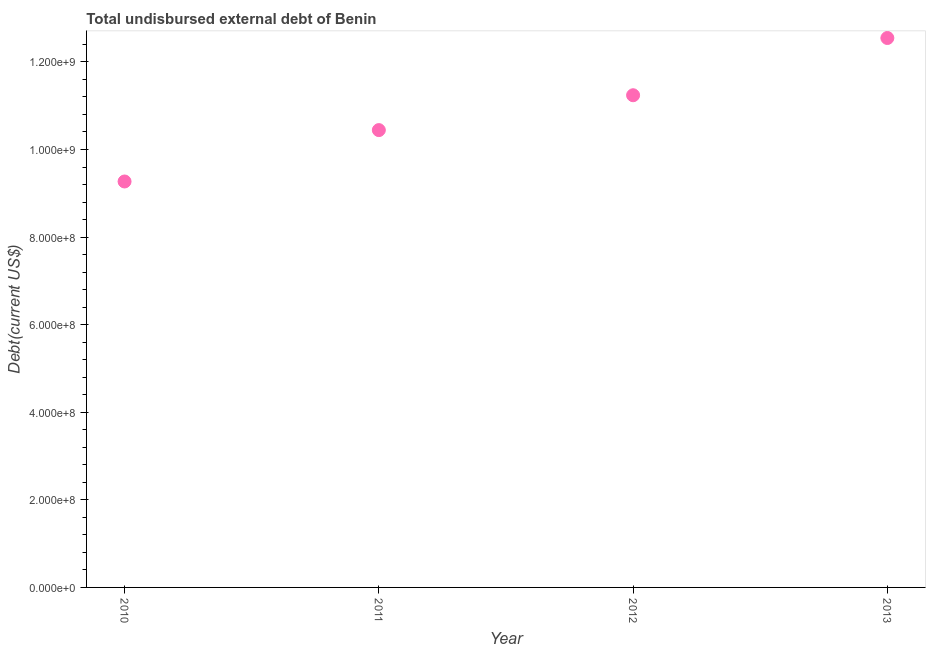What is the total debt in 2013?
Your response must be concise. 1.25e+09. Across all years, what is the maximum total debt?
Ensure brevity in your answer.  1.25e+09. Across all years, what is the minimum total debt?
Your answer should be very brief. 9.27e+08. In which year was the total debt maximum?
Your answer should be very brief. 2013. In which year was the total debt minimum?
Your response must be concise. 2010. What is the sum of the total debt?
Provide a succinct answer. 4.35e+09. What is the difference between the total debt in 2010 and 2011?
Provide a short and direct response. -1.17e+08. What is the average total debt per year?
Your answer should be compact. 1.09e+09. What is the median total debt?
Your response must be concise. 1.08e+09. In how many years, is the total debt greater than 1080000000 US$?
Provide a succinct answer. 2. Do a majority of the years between 2010 and 2012 (inclusive) have total debt greater than 440000000 US$?
Your answer should be very brief. Yes. What is the ratio of the total debt in 2010 to that in 2013?
Your answer should be very brief. 0.74. Is the total debt in 2010 less than that in 2012?
Offer a terse response. Yes. What is the difference between the highest and the second highest total debt?
Your answer should be compact. 1.31e+08. Is the sum of the total debt in 2012 and 2013 greater than the maximum total debt across all years?
Make the answer very short. Yes. What is the difference between the highest and the lowest total debt?
Provide a short and direct response. 3.28e+08. How many dotlines are there?
Your response must be concise. 1. Does the graph contain grids?
Give a very brief answer. No. What is the title of the graph?
Provide a succinct answer. Total undisbursed external debt of Benin. What is the label or title of the X-axis?
Your response must be concise. Year. What is the label or title of the Y-axis?
Your response must be concise. Debt(current US$). What is the Debt(current US$) in 2010?
Provide a succinct answer. 9.27e+08. What is the Debt(current US$) in 2011?
Offer a terse response. 1.04e+09. What is the Debt(current US$) in 2012?
Your answer should be very brief. 1.12e+09. What is the Debt(current US$) in 2013?
Your answer should be very brief. 1.25e+09. What is the difference between the Debt(current US$) in 2010 and 2011?
Your answer should be compact. -1.17e+08. What is the difference between the Debt(current US$) in 2010 and 2012?
Provide a short and direct response. -1.97e+08. What is the difference between the Debt(current US$) in 2010 and 2013?
Give a very brief answer. -3.28e+08. What is the difference between the Debt(current US$) in 2011 and 2012?
Your response must be concise. -7.96e+07. What is the difference between the Debt(current US$) in 2011 and 2013?
Provide a short and direct response. -2.10e+08. What is the difference between the Debt(current US$) in 2012 and 2013?
Provide a short and direct response. -1.31e+08. What is the ratio of the Debt(current US$) in 2010 to that in 2011?
Provide a succinct answer. 0.89. What is the ratio of the Debt(current US$) in 2010 to that in 2012?
Your answer should be compact. 0.82. What is the ratio of the Debt(current US$) in 2010 to that in 2013?
Your response must be concise. 0.74. What is the ratio of the Debt(current US$) in 2011 to that in 2012?
Offer a very short reply. 0.93. What is the ratio of the Debt(current US$) in 2011 to that in 2013?
Offer a terse response. 0.83. What is the ratio of the Debt(current US$) in 2012 to that in 2013?
Your answer should be very brief. 0.9. 